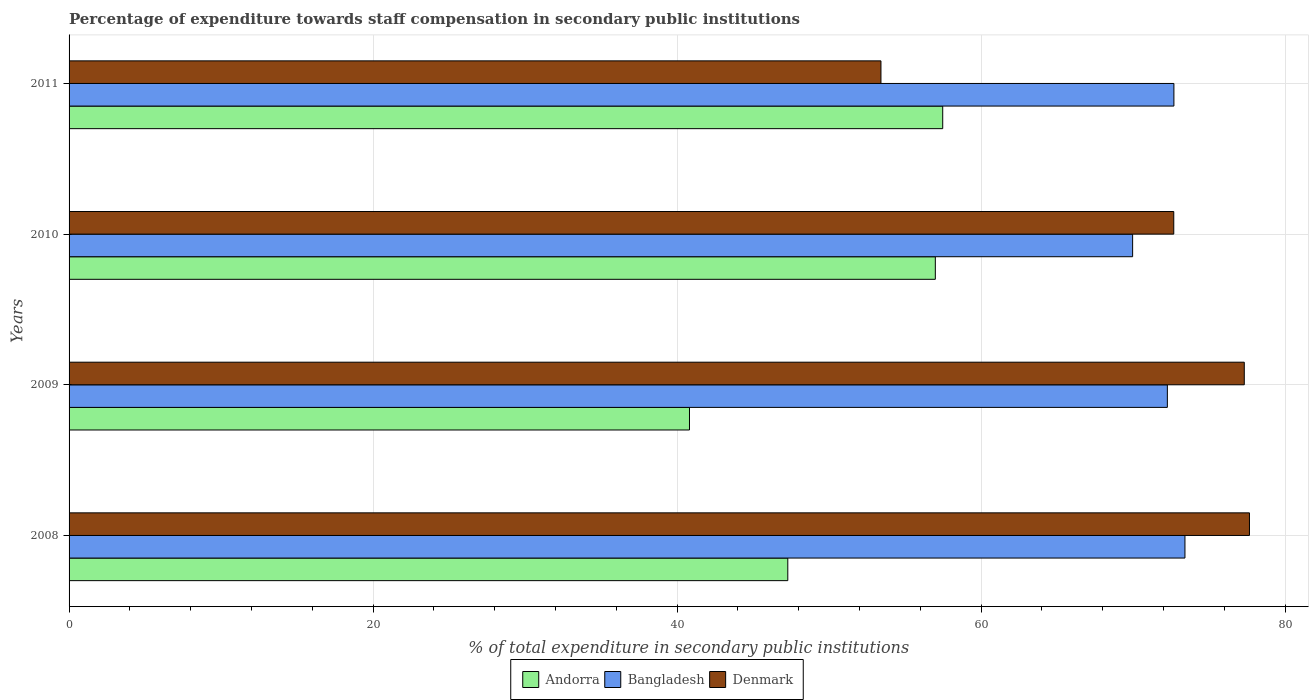How many groups of bars are there?
Your answer should be compact. 4. How many bars are there on the 1st tick from the top?
Offer a very short reply. 3. How many bars are there on the 1st tick from the bottom?
Make the answer very short. 3. What is the label of the 1st group of bars from the top?
Offer a very short reply. 2011. What is the percentage of expenditure towards staff compensation in Andorra in 2010?
Give a very brief answer. 56.99. Across all years, what is the maximum percentage of expenditure towards staff compensation in Bangladesh?
Make the answer very short. 73.42. Across all years, what is the minimum percentage of expenditure towards staff compensation in Bangladesh?
Your response must be concise. 69.97. In which year was the percentage of expenditure towards staff compensation in Andorra maximum?
Provide a short and direct response. 2011. What is the total percentage of expenditure towards staff compensation in Denmark in the graph?
Make the answer very short. 281.08. What is the difference between the percentage of expenditure towards staff compensation in Bangladesh in 2009 and that in 2011?
Your answer should be very brief. -0.43. What is the difference between the percentage of expenditure towards staff compensation in Denmark in 2009 and the percentage of expenditure towards staff compensation in Andorra in 2011?
Offer a very short reply. 19.84. What is the average percentage of expenditure towards staff compensation in Denmark per year?
Your answer should be very brief. 70.27. In the year 2008, what is the difference between the percentage of expenditure towards staff compensation in Denmark and percentage of expenditure towards staff compensation in Bangladesh?
Your answer should be compact. 4.25. What is the ratio of the percentage of expenditure towards staff compensation in Bangladesh in 2008 to that in 2011?
Make the answer very short. 1.01. Is the percentage of expenditure towards staff compensation in Denmark in 2009 less than that in 2010?
Keep it short and to the point. No. Is the difference between the percentage of expenditure towards staff compensation in Denmark in 2008 and 2009 greater than the difference between the percentage of expenditure towards staff compensation in Bangladesh in 2008 and 2009?
Your answer should be very brief. No. What is the difference between the highest and the second highest percentage of expenditure towards staff compensation in Denmark?
Keep it short and to the point. 0.34. What is the difference between the highest and the lowest percentage of expenditure towards staff compensation in Andorra?
Your answer should be compact. 16.66. Are all the bars in the graph horizontal?
Provide a succinct answer. Yes. How many years are there in the graph?
Keep it short and to the point. 4. What is the difference between two consecutive major ticks on the X-axis?
Offer a terse response. 20. Are the values on the major ticks of X-axis written in scientific E-notation?
Provide a succinct answer. No. Does the graph contain any zero values?
Provide a succinct answer. No. What is the title of the graph?
Provide a succinct answer. Percentage of expenditure towards staff compensation in secondary public institutions. Does "Fragile and conflict affected situations" appear as one of the legend labels in the graph?
Offer a terse response. No. What is the label or title of the X-axis?
Make the answer very short. % of total expenditure in secondary public institutions. What is the label or title of the Y-axis?
Make the answer very short. Years. What is the % of total expenditure in secondary public institutions of Andorra in 2008?
Give a very brief answer. 47.29. What is the % of total expenditure in secondary public institutions in Bangladesh in 2008?
Give a very brief answer. 73.42. What is the % of total expenditure in secondary public institutions of Denmark in 2008?
Offer a terse response. 77.66. What is the % of total expenditure in secondary public institutions in Andorra in 2009?
Provide a succinct answer. 40.82. What is the % of total expenditure in secondary public institutions of Bangladesh in 2009?
Your answer should be compact. 72.26. What is the % of total expenditure in secondary public institutions of Denmark in 2009?
Provide a short and direct response. 77.32. What is the % of total expenditure in secondary public institutions of Andorra in 2010?
Ensure brevity in your answer.  56.99. What is the % of total expenditure in secondary public institutions of Bangladesh in 2010?
Offer a terse response. 69.97. What is the % of total expenditure in secondary public institutions in Denmark in 2010?
Your answer should be compact. 72.68. What is the % of total expenditure in secondary public institutions in Andorra in 2011?
Offer a very short reply. 57.48. What is the % of total expenditure in secondary public institutions of Bangladesh in 2011?
Give a very brief answer. 72.69. What is the % of total expenditure in secondary public institutions in Denmark in 2011?
Provide a succinct answer. 53.42. Across all years, what is the maximum % of total expenditure in secondary public institutions in Andorra?
Offer a terse response. 57.48. Across all years, what is the maximum % of total expenditure in secondary public institutions of Bangladesh?
Make the answer very short. 73.42. Across all years, what is the maximum % of total expenditure in secondary public institutions of Denmark?
Ensure brevity in your answer.  77.66. Across all years, what is the minimum % of total expenditure in secondary public institutions of Andorra?
Give a very brief answer. 40.82. Across all years, what is the minimum % of total expenditure in secondary public institutions of Bangladesh?
Offer a terse response. 69.97. Across all years, what is the minimum % of total expenditure in secondary public institutions of Denmark?
Give a very brief answer. 53.42. What is the total % of total expenditure in secondary public institutions in Andorra in the graph?
Ensure brevity in your answer.  202.58. What is the total % of total expenditure in secondary public institutions of Bangladesh in the graph?
Give a very brief answer. 288.34. What is the total % of total expenditure in secondary public institutions of Denmark in the graph?
Provide a short and direct response. 281.08. What is the difference between the % of total expenditure in secondary public institutions in Andorra in 2008 and that in 2009?
Ensure brevity in your answer.  6.47. What is the difference between the % of total expenditure in secondary public institutions of Bangladesh in 2008 and that in 2009?
Ensure brevity in your answer.  1.16. What is the difference between the % of total expenditure in secondary public institutions in Denmark in 2008 and that in 2009?
Give a very brief answer. 0.34. What is the difference between the % of total expenditure in secondary public institutions in Andorra in 2008 and that in 2010?
Make the answer very short. -9.71. What is the difference between the % of total expenditure in secondary public institutions in Bangladesh in 2008 and that in 2010?
Make the answer very short. 3.44. What is the difference between the % of total expenditure in secondary public institutions in Denmark in 2008 and that in 2010?
Your response must be concise. 4.98. What is the difference between the % of total expenditure in secondary public institutions in Andorra in 2008 and that in 2011?
Offer a terse response. -10.19. What is the difference between the % of total expenditure in secondary public institutions of Bangladesh in 2008 and that in 2011?
Your answer should be compact. 0.73. What is the difference between the % of total expenditure in secondary public institutions in Denmark in 2008 and that in 2011?
Offer a very short reply. 24.25. What is the difference between the % of total expenditure in secondary public institutions of Andorra in 2009 and that in 2010?
Keep it short and to the point. -16.18. What is the difference between the % of total expenditure in secondary public institutions of Bangladesh in 2009 and that in 2010?
Give a very brief answer. 2.29. What is the difference between the % of total expenditure in secondary public institutions in Denmark in 2009 and that in 2010?
Make the answer very short. 4.64. What is the difference between the % of total expenditure in secondary public institutions of Andorra in 2009 and that in 2011?
Make the answer very short. -16.66. What is the difference between the % of total expenditure in secondary public institutions of Bangladesh in 2009 and that in 2011?
Provide a short and direct response. -0.43. What is the difference between the % of total expenditure in secondary public institutions of Denmark in 2009 and that in 2011?
Offer a terse response. 23.9. What is the difference between the % of total expenditure in secondary public institutions in Andorra in 2010 and that in 2011?
Keep it short and to the point. -0.49. What is the difference between the % of total expenditure in secondary public institutions of Bangladesh in 2010 and that in 2011?
Give a very brief answer. -2.72. What is the difference between the % of total expenditure in secondary public institutions in Denmark in 2010 and that in 2011?
Your answer should be compact. 19.27. What is the difference between the % of total expenditure in secondary public institutions in Andorra in 2008 and the % of total expenditure in secondary public institutions in Bangladesh in 2009?
Your answer should be very brief. -24.97. What is the difference between the % of total expenditure in secondary public institutions of Andorra in 2008 and the % of total expenditure in secondary public institutions of Denmark in 2009?
Provide a succinct answer. -30.03. What is the difference between the % of total expenditure in secondary public institutions in Bangladesh in 2008 and the % of total expenditure in secondary public institutions in Denmark in 2009?
Provide a succinct answer. -3.9. What is the difference between the % of total expenditure in secondary public institutions in Andorra in 2008 and the % of total expenditure in secondary public institutions in Bangladesh in 2010?
Your answer should be very brief. -22.69. What is the difference between the % of total expenditure in secondary public institutions of Andorra in 2008 and the % of total expenditure in secondary public institutions of Denmark in 2010?
Give a very brief answer. -25.39. What is the difference between the % of total expenditure in secondary public institutions of Bangladesh in 2008 and the % of total expenditure in secondary public institutions of Denmark in 2010?
Provide a succinct answer. 0.74. What is the difference between the % of total expenditure in secondary public institutions of Andorra in 2008 and the % of total expenditure in secondary public institutions of Bangladesh in 2011?
Your response must be concise. -25.4. What is the difference between the % of total expenditure in secondary public institutions in Andorra in 2008 and the % of total expenditure in secondary public institutions in Denmark in 2011?
Offer a very short reply. -6.13. What is the difference between the % of total expenditure in secondary public institutions in Bangladesh in 2008 and the % of total expenditure in secondary public institutions in Denmark in 2011?
Your answer should be compact. 20. What is the difference between the % of total expenditure in secondary public institutions of Andorra in 2009 and the % of total expenditure in secondary public institutions of Bangladesh in 2010?
Your response must be concise. -29.16. What is the difference between the % of total expenditure in secondary public institutions in Andorra in 2009 and the % of total expenditure in secondary public institutions in Denmark in 2010?
Make the answer very short. -31.86. What is the difference between the % of total expenditure in secondary public institutions of Bangladesh in 2009 and the % of total expenditure in secondary public institutions of Denmark in 2010?
Offer a very short reply. -0.42. What is the difference between the % of total expenditure in secondary public institutions of Andorra in 2009 and the % of total expenditure in secondary public institutions of Bangladesh in 2011?
Ensure brevity in your answer.  -31.87. What is the difference between the % of total expenditure in secondary public institutions of Andorra in 2009 and the % of total expenditure in secondary public institutions of Denmark in 2011?
Provide a short and direct response. -12.6. What is the difference between the % of total expenditure in secondary public institutions in Bangladesh in 2009 and the % of total expenditure in secondary public institutions in Denmark in 2011?
Keep it short and to the point. 18.84. What is the difference between the % of total expenditure in secondary public institutions in Andorra in 2010 and the % of total expenditure in secondary public institutions in Bangladesh in 2011?
Your answer should be compact. -15.7. What is the difference between the % of total expenditure in secondary public institutions of Andorra in 2010 and the % of total expenditure in secondary public institutions of Denmark in 2011?
Offer a terse response. 3.58. What is the difference between the % of total expenditure in secondary public institutions in Bangladesh in 2010 and the % of total expenditure in secondary public institutions in Denmark in 2011?
Make the answer very short. 16.56. What is the average % of total expenditure in secondary public institutions of Andorra per year?
Offer a very short reply. 50.65. What is the average % of total expenditure in secondary public institutions of Bangladesh per year?
Ensure brevity in your answer.  72.09. What is the average % of total expenditure in secondary public institutions in Denmark per year?
Offer a terse response. 70.27. In the year 2008, what is the difference between the % of total expenditure in secondary public institutions of Andorra and % of total expenditure in secondary public institutions of Bangladesh?
Your response must be concise. -26.13. In the year 2008, what is the difference between the % of total expenditure in secondary public institutions of Andorra and % of total expenditure in secondary public institutions of Denmark?
Ensure brevity in your answer.  -30.37. In the year 2008, what is the difference between the % of total expenditure in secondary public institutions of Bangladesh and % of total expenditure in secondary public institutions of Denmark?
Give a very brief answer. -4.25. In the year 2009, what is the difference between the % of total expenditure in secondary public institutions in Andorra and % of total expenditure in secondary public institutions in Bangladesh?
Keep it short and to the point. -31.44. In the year 2009, what is the difference between the % of total expenditure in secondary public institutions in Andorra and % of total expenditure in secondary public institutions in Denmark?
Your answer should be very brief. -36.5. In the year 2009, what is the difference between the % of total expenditure in secondary public institutions in Bangladesh and % of total expenditure in secondary public institutions in Denmark?
Keep it short and to the point. -5.06. In the year 2010, what is the difference between the % of total expenditure in secondary public institutions of Andorra and % of total expenditure in secondary public institutions of Bangladesh?
Your answer should be very brief. -12.98. In the year 2010, what is the difference between the % of total expenditure in secondary public institutions of Andorra and % of total expenditure in secondary public institutions of Denmark?
Ensure brevity in your answer.  -15.69. In the year 2010, what is the difference between the % of total expenditure in secondary public institutions in Bangladesh and % of total expenditure in secondary public institutions in Denmark?
Keep it short and to the point. -2.71. In the year 2011, what is the difference between the % of total expenditure in secondary public institutions in Andorra and % of total expenditure in secondary public institutions in Bangladesh?
Your response must be concise. -15.21. In the year 2011, what is the difference between the % of total expenditure in secondary public institutions of Andorra and % of total expenditure in secondary public institutions of Denmark?
Your answer should be compact. 4.06. In the year 2011, what is the difference between the % of total expenditure in secondary public institutions of Bangladesh and % of total expenditure in secondary public institutions of Denmark?
Offer a very short reply. 19.28. What is the ratio of the % of total expenditure in secondary public institutions in Andorra in 2008 to that in 2009?
Offer a very short reply. 1.16. What is the ratio of the % of total expenditure in secondary public institutions of Bangladesh in 2008 to that in 2009?
Offer a terse response. 1.02. What is the ratio of the % of total expenditure in secondary public institutions of Andorra in 2008 to that in 2010?
Give a very brief answer. 0.83. What is the ratio of the % of total expenditure in secondary public institutions of Bangladesh in 2008 to that in 2010?
Your answer should be compact. 1.05. What is the ratio of the % of total expenditure in secondary public institutions in Denmark in 2008 to that in 2010?
Offer a terse response. 1.07. What is the ratio of the % of total expenditure in secondary public institutions in Andorra in 2008 to that in 2011?
Your answer should be compact. 0.82. What is the ratio of the % of total expenditure in secondary public institutions in Bangladesh in 2008 to that in 2011?
Offer a terse response. 1.01. What is the ratio of the % of total expenditure in secondary public institutions of Denmark in 2008 to that in 2011?
Keep it short and to the point. 1.45. What is the ratio of the % of total expenditure in secondary public institutions of Andorra in 2009 to that in 2010?
Give a very brief answer. 0.72. What is the ratio of the % of total expenditure in secondary public institutions in Bangladesh in 2009 to that in 2010?
Ensure brevity in your answer.  1.03. What is the ratio of the % of total expenditure in secondary public institutions of Denmark in 2009 to that in 2010?
Your answer should be very brief. 1.06. What is the ratio of the % of total expenditure in secondary public institutions in Andorra in 2009 to that in 2011?
Provide a short and direct response. 0.71. What is the ratio of the % of total expenditure in secondary public institutions in Bangladesh in 2009 to that in 2011?
Provide a short and direct response. 0.99. What is the ratio of the % of total expenditure in secondary public institutions in Denmark in 2009 to that in 2011?
Keep it short and to the point. 1.45. What is the ratio of the % of total expenditure in secondary public institutions in Bangladesh in 2010 to that in 2011?
Give a very brief answer. 0.96. What is the ratio of the % of total expenditure in secondary public institutions of Denmark in 2010 to that in 2011?
Your answer should be very brief. 1.36. What is the difference between the highest and the second highest % of total expenditure in secondary public institutions of Andorra?
Offer a very short reply. 0.49. What is the difference between the highest and the second highest % of total expenditure in secondary public institutions in Bangladesh?
Offer a very short reply. 0.73. What is the difference between the highest and the second highest % of total expenditure in secondary public institutions in Denmark?
Ensure brevity in your answer.  0.34. What is the difference between the highest and the lowest % of total expenditure in secondary public institutions of Andorra?
Offer a very short reply. 16.66. What is the difference between the highest and the lowest % of total expenditure in secondary public institutions of Bangladesh?
Your answer should be compact. 3.44. What is the difference between the highest and the lowest % of total expenditure in secondary public institutions of Denmark?
Give a very brief answer. 24.25. 